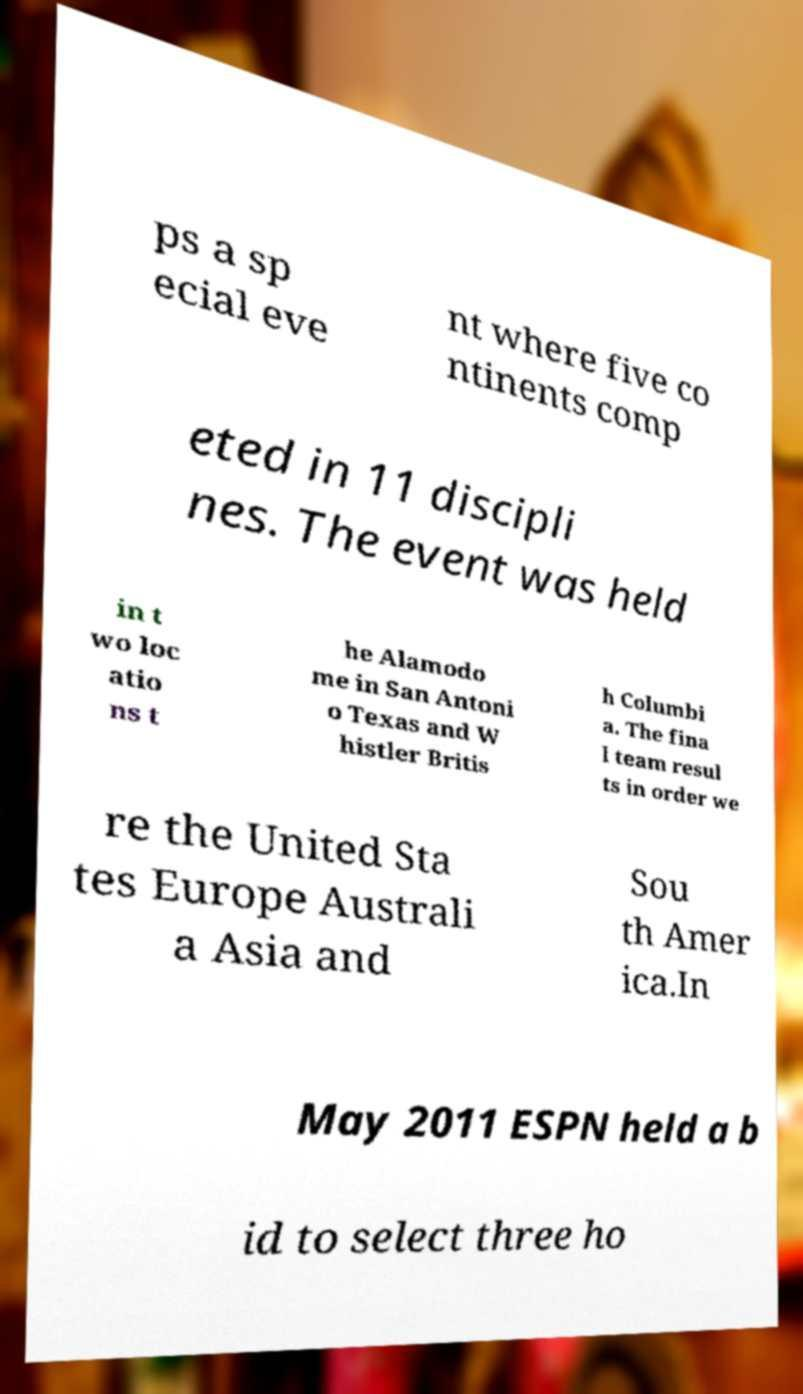What messages or text are displayed in this image? I need them in a readable, typed format. ps a sp ecial eve nt where five co ntinents comp eted in 11 discipli nes. The event was held in t wo loc atio ns t he Alamodo me in San Antoni o Texas and W histler Britis h Columbi a. The fina l team resul ts in order we re the United Sta tes Europe Australi a Asia and Sou th Amer ica.In May 2011 ESPN held a b id to select three ho 